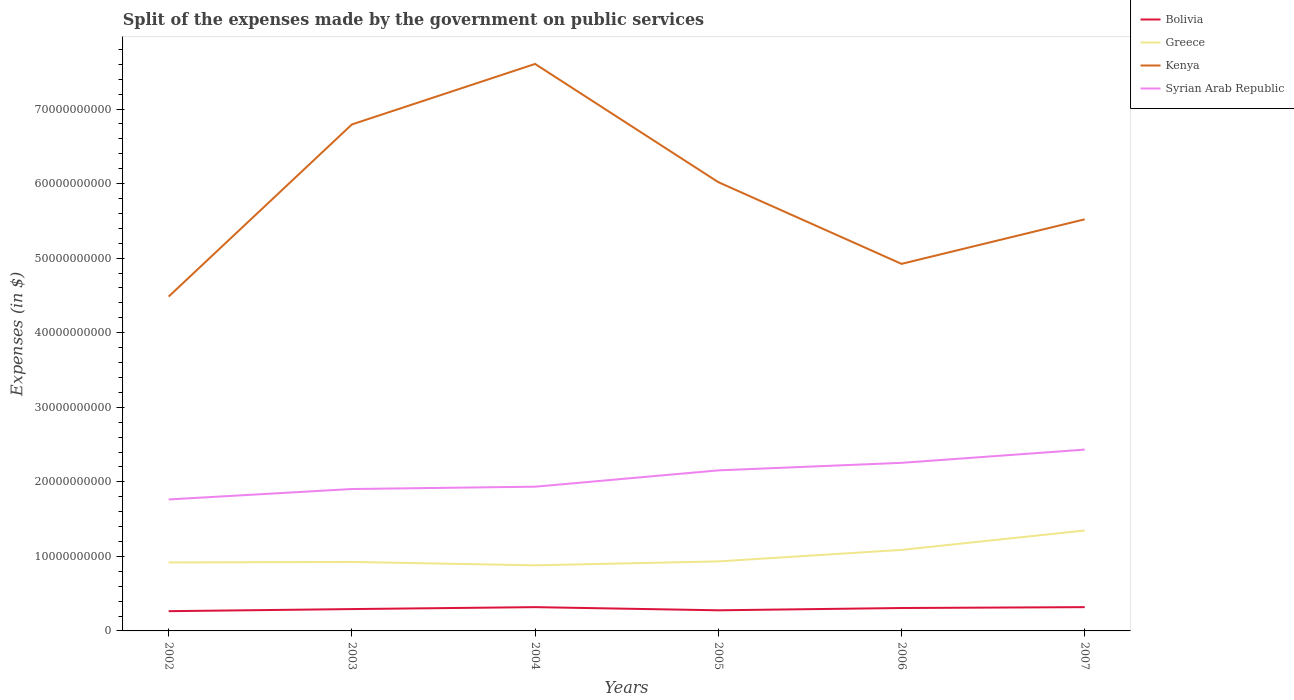Is the number of lines equal to the number of legend labels?
Keep it short and to the point. Yes. Across all years, what is the maximum expenses made by the government on public services in Bolivia?
Keep it short and to the point. 2.65e+09. In which year was the expenses made by the government on public services in Greece maximum?
Your answer should be compact. 2004. What is the total expenses made by the government on public services in Syrian Arab Republic in the graph?
Ensure brevity in your answer.  -3.90e+09. What is the difference between the highest and the second highest expenses made by the government on public services in Kenya?
Your answer should be very brief. 3.12e+1. What is the difference between the highest and the lowest expenses made by the government on public services in Kenya?
Your answer should be compact. 3. How many lines are there?
Your response must be concise. 4. How many years are there in the graph?
Ensure brevity in your answer.  6. Where does the legend appear in the graph?
Keep it short and to the point. Top right. How many legend labels are there?
Your answer should be very brief. 4. What is the title of the graph?
Your answer should be very brief. Split of the expenses made by the government on public services. Does "Suriname" appear as one of the legend labels in the graph?
Make the answer very short. No. What is the label or title of the X-axis?
Your answer should be very brief. Years. What is the label or title of the Y-axis?
Make the answer very short. Expenses (in $). What is the Expenses (in $) of Bolivia in 2002?
Make the answer very short. 2.65e+09. What is the Expenses (in $) in Greece in 2002?
Provide a succinct answer. 9.18e+09. What is the Expenses (in $) of Kenya in 2002?
Your answer should be compact. 4.49e+1. What is the Expenses (in $) in Syrian Arab Republic in 2002?
Your answer should be compact. 1.76e+1. What is the Expenses (in $) in Bolivia in 2003?
Give a very brief answer. 2.93e+09. What is the Expenses (in $) in Greece in 2003?
Your answer should be very brief. 9.25e+09. What is the Expenses (in $) in Kenya in 2003?
Ensure brevity in your answer.  6.79e+1. What is the Expenses (in $) of Syrian Arab Republic in 2003?
Keep it short and to the point. 1.90e+1. What is the Expenses (in $) of Bolivia in 2004?
Make the answer very short. 3.19e+09. What is the Expenses (in $) of Greece in 2004?
Provide a short and direct response. 8.80e+09. What is the Expenses (in $) in Kenya in 2004?
Offer a very short reply. 7.61e+1. What is the Expenses (in $) of Syrian Arab Republic in 2004?
Offer a very short reply. 1.93e+1. What is the Expenses (in $) of Bolivia in 2005?
Offer a very short reply. 2.77e+09. What is the Expenses (in $) in Greece in 2005?
Offer a terse response. 9.33e+09. What is the Expenses (in $) of Kenya in 2005?
Give a very brief answer. 6.02e+1. What is the Expenses (in $) of Syrian Arab Republic in 2005?
Your response must be concise. 2.15e+1. What is the Expenses (in $) in Bolivia in 2006?
Offer a terse response. 3.07e+09. What is the Expenses (in $) in Greece in 2006?
Your response must be concise. 1.09e+1. What is the Expenses (in $) of Kenya in 2006?
Provide a succinct answer. 4.92e+1. What is the Expenses (in $) in Syrian Arab Republic in 2006?
Your answer should be compact. 2.25e+1. What is the Expenses (in $) in Bolivia in 2007?
Give a very brief answer. 3.19e+09. What is the Expenses (in $) in Greece in 2007?
Your response must be concise. 1.35e+1. What is the Expenses (in $) in Kenya in 2007?
Provide a short and direct response. 5.52e+1. What is the Expenses (in $) of Syrian Arab Republic in 2007?
Your answer should be very brief. 2.43e+1. Across all years, what is the maximum Expenses (in $) of Bolivia?
Ensure brevity in your answer.  3.19e+09. Across all years, what is the maximum Expenses (in $) in Greece?
Your answer should be compact. 1.35e+1. Across all years, what is the maximum Expenses (in $) of Kenya?
Your response must be concise. 7.61e+1. Across all years, what is the maximum Expenses (in $) in Syrian Arab Republic?
Your answer should be very brief. 2.43e+1. Across all years, what is the minimum Expenses (in $) in Bolivia?
Make the answer very short. 2.65e+09. Across all years, what is the minimum Expenses (in $) of Greece?
Give a very brief answer. 8.80e+09. Across all years, what is the minimum Expenses (in $) in Kenya?
Provide a short and direct response. 4.49e+1. Across all years, what is the minimum Expenses (in $) in Syrian Arab Republic?
Your response must be concise. 1.76e+1. What is the total Expenses (in $) in Bolivia in the graph?
Offer a terse response. 1.78e+1. What is the total Expenses (in $) of Greece in the graph?
Offer a terse response. 6.09e+1. What is the total Expenses (in $) of Kenya in the graph?
Make the answer very short. 3.53e+11. What is the total Expenses (in $) of Syrian Arab Republic in the graph?
Keep it short and to the point. 1.24e+11. What is the difference between the Expenses (in $) in Bolivia in 2002 and that in 2003?
Offer a very short reply. -2.81e+08. What is the difference between the Expenses (in $) of Greece in 2002 and that in 2003?
Your answer should be very brief. -7.00e+07. What is the difference between the Expenses (in $) of Kenya in 2002 and that in 2003?
Your answer should be compact. -2.31e+1. What is the difference between the Expenses (in $) of Syrian Arab Republic in 2002 and that in 2003?
Your response must be concise. -1.40e+09. What is the difference between the Expenses (in $) in Bolivia in 2002 and that in 2004?
Your answer should be very brief. -5.42e+08. What is the difference between the Expenses (in $) in Greece in 2002 and that in 2004?
Your answer should be compact. 3.84e+08. What is the difference between the Expenses (in $) of Kenya in 2002 and that in 2004?
Your answer should be compact. -3.12e+1. What is the difference between the Expenses (in $) in Syrian Arab Republic in 2002 and that in 2004?
Make the answer very short. -1.71e+09. What is the difference between the Expenses (in $) in Bolivia in 2002 and that in 2005?
Ensure brevity in your answer.  -1.18e+08. What is the difference between the Expenses (in $) in Greece in 2002 and that in 2005?
Your answer should be compact. -1.44e+08. What is the difference between the Expenses (in $) in Kenya in 2002 and that in 2005?
Your response must be concise. -1.53e+1. What is the difference between the Expenses (in $) in Syrian Arab Republic in 2002 and that in 2005?
Keep it short and to the point. -3.90e+09. What is the difference between the Expenses (in $) in Bolivia in 2002 and that in 2006?
Your answer should be compact. -4.25e+08. What is the difference between the Expenses (in $) of Greece in 2002 and that in 2006?
Your answer should be compact. -1.69e+09. What is the difference between the Expenses (in $) of Kenya in 2002 and that in 2006?
Your answer should be compact. -4.39e+09. What is the difference between the Expenses (in $) of Syrian Arab Republic in 2002 and that in 2006?
Provide a succinct answer. -4.91e+09. What is the difference between the Expenses (in $) in Bolivia in 2002 and that in 2007?
Give a very brief answer. -5.41e+08. What is the difference between the Expenses (in $) of Greece in 2002 and that in 2007?
Offer a terse response. -4.29e+09. What is the difference between the Expenses (in $) in Kenya in 2002 and that in 2007?
Offer a very short reply. -1.04e+1. What is the difference between the Expenses (in $) in Syrian Arab Republic in 2002 and that in 2007?
Provide a short and direct response. -6.68e+09. What is the difference between the Expenses (in $) in Bolivia in 2003 and that in 2004?
Your response must be concise. -2.61e+08. What is the difference between the Expenses (in $) in Greece in 2003 and that in 2004?
Give a very brief answer. 4.54e+08. What is the difference between the Expenses (in $) in Kenya in 2003 and that in 2004?
Provide a succinct answer. -8.12e+09. What is the difference between the Expenses (in $) of Syrian Arab Republic in 2003 and that in 2004?
Provide a succinct answer. -3.12e+08. What is the difference between the Expenses (in $) of Bolivia in 2003 and that in 2005?
Offer a terse response. 1.63e+08. What is the difference between the Expenses (in $) of Greece in 2003 and that in 2005?
Ensure brevity in your answer.  -7.40e+07. What is the difference between the Expenses (in $) in Kenya in 2003 and that in 2005?
Keep it short and to the point. 7.74e+09. What is the difference between the Expenses (in $) of Syrian Arab Republic in 2003 and that in 2005?
Offer a very short reply. -2.50e+09. What is the difference between the Expenses (in $) in Bolivia in 2003 and that in 2006?
Make the answer very short. -1.43e+08. What is the difference between the Expenses (in $) in Greece in 2003 and that in 2006?
Give a very brief answer. -1.62e+09. What is the difference between the Expenses (in $) of Kenya in 2003 and that in 2006?
Your answer should be very brief. 1.87e+1. What is the difference between the Expenses (in $) in Syrian Arab Republic in 2003 and that in 2006?
Your answer should be very brief. -3.51e+09. What is the difference between the Expenses (in $) of Bolivia in 2003 and that in 2007?
Offer a terse response. -2.60e+08. What is the difference between the Expenses (in $) in Greece in 2003 and that in 2007?
Your answer should be compact. -4.22e+09. What is the difference between the Expenses (in $) in Kenya in 2003 and that in 2007?
Offer a terse response. 1.27e+1. What is the difference between the Expenses (in $) in Syrian Arab Republic in 2003 and that in 2007?
Offer a terse response. -5.29e+09. What is the difference between the Expenses (in $) in Bolivia in 2004 and that in 2005?
Give a very brief answer. 4.24e+08. What is the difference between the Expenses (in $) in Greece in 2004 and that in 2005?
Offer a terse response. -5.28e+08. What is the difference between the Expenses (in $) in Kenya in 2004 and that in 2005?
Your answer should be very brief. 1.59e+1. What is the difference between the Expenses (in $) in Syrian Arab Republic in 2004 and that in 2005?
Keep it short and to the point. -2.19e+09. What is the difference between the Expenses (in $) in Bolivia in 2004 and that in 2006?
Make the answer very short. 1.18e+08. What is the difference between the Expenses (in $) in Greece in 2004 and that in 2006?
Your answer should be compact. -2.07e+09. What is the difference between the Expenses (in $) of Kenya in 2004 and that in 2006?
Offer a very short reply. 2.68e+1. What is the difference between the Expenses (in $) in Syrian Arab Republic in 2004 and that in 2006?
Give a very brief answer. -3.20e+09. What is the difference between the Expenses (in $) of Bolivia in 2004 and that in 2007?
Give a very brief answer. 8.21e+05. What is the difference between the Expenses (in $) in Greece in 2004 and that in 2007?
Offer a very short reply. -4.67e+09. What is the difference between the Expenses (in $) of Kenya in 2004 and that in 2007?
Provide a short and direct response. 2.08e+1. What is the difference between the Expenses (in $) of Syrian Arab Republic in 2004 and that in 2007?
Your answer should be compact. -4.97e+09. What is the difference between the Expenses (in $) in Bolivia in 2005 and that in 2006?
Your answer should be very brief. -3.06e+08. What is the difference between the Expenses (in $) of Greece in 2005 and that in 2006?
Your answer should be very brief. -1.54e+09. What is the difference between the Expenses (in $) in Kenya in 2005 and that in 2006?
Your answer should be compact. 1.10e+1. What is the difference between the Expenses (in $) of Syrian Arab Republic in 2005 and that in 2006?
Your answer should be compact. -1.01e+09. What is the difference between the Expenses (in $) of Bolivia in 2005 and that in 2007?
Your answer should be very brief. -4.23e+08. What is the difference between the Expenses (in $) of Greece in 2005 and that in 2007?
Your response must be concise. -4.14e+09. What is the difference between the Expenses (in $) of Kenya in 2005 and that in 2007?
Offer a terse response. 4.99e+09. What is the difference between the Expenses (in $) in Syrian Arab Republic in 2005 and that in 2007?
Give a very brief answer. -2.79e+09. What is the difference between the Expenses (in $) of Bolivia in 2006 and that in 2007?
Provide a succinct answer. -1.17e+08. What is the difference between the Expenses (in $) of Greece in 2006 and that in 2007?
Offer a terse response. -2.60e+09. What is the difference between the Expenses (in $) of Kenya in 2006 and that in 2007?
Your response must be concise. -5.98e+09. What is the difference between the Expenses (in $) of Syrian Arab Republic in 2006 and that in 2007?
Give a very brief answer. -1.78e+09. What is the difference between the Expenses (in $) in Bolivia in 2002 and the Expenses (in $) in Greece in 2003?
Your answer should be very brief. -6.60e+09. What is the difference between the Expenses (in $) of Bolivia in 2002 and the Expenses (in $) of Kenya in 2003?
Ensure brevity in your answer.  -6.53e+1. What is the difference between the Expenses (in $) of Bolivia in 2002 and the Expenses (in $) of Syrian Arab Republic in 2003?
Offer a very short reply. -1.64e+1. What is the difference between the Expenses (in $) in Greece in 2002 and the Expenses (in $) in Kenya in 2003?
Provide a succinct answer. -5.88e+1. What is the difference between the Expenses (in $) of Greece in 2002 and the Expenses (in $) of Syrian Arab Republic in 2003?
Keep it short and to the point. -9.85e+09. What is the difference between the Expenses (in $) in Kenya in 2002 and the Expenses (in $) in Syrian Arab Republic in 2003?
Offer a terse response. 2.58e+1. What is the difference between the Expenses (in $) in Bolivia in 2002 and the Expenses (in $) in Greece in 2004?
Ensure brevity in your answer.  -6.15e+09. What is the difference between the Expenses (in $) of Bolivia in 2002 and the Expenses (in $) of Kenya in 2004?
Offer a very short reply. -7.34e+1. What is the difference between the Expenses (in $) in Bolivia in 2002 and the Expenses (in $) in Syrian Arab Republic in 2004?
Ensure brevity in your answer.  -1.67e+1. What is the difference between the Expenses (in $) in Greece in 2002 and the Expenses (in $) in Kenya in 2004?
Your response must be concise. -6.69e+1. What is the difference between the Expenses (in $) in Greece in 2002 and the Expenses (in $) in Syrian Arab Republic in 2004?
Keep it short and to the point. -1.02e+1. What is the difference between the Expenses (in $) in Kenya in 2002 and the Expenses (in $) in Syrian Arab Republic in 2004?
Provide a succinct answer. 2.55e+1. What is the difference between the Expenses (in $) in Bolivia in 2002 and the Expenses (in $) in Greece in 2005?
Make the answer very short. -6.68e+09. What is the difference between the Expenses (in $) of Bolivia in 2002 and the Expenses (in $) of Kenya in 2005?
Make the answer very short. -5.75e+1. What is the difference between the Expenses (in $) of Bolivia in 2002 and the Expenses (in $) of Syrian Arab Republic in 2005?
Ensure brevity in your answer.  -1.89e+1. What is the difference between the Expenses (in $) of Greece in 2002 and the Expenses (in $) of Kenya in 2005?
Give a very brief answer. -5.10e+1. What is the difference between the Expenses (in $) of Greece in 2002 and the Expenses (in $) of Syrian Arab Republic in 2005?
Provide a succinct answer. -1.24e+1. What is the difference between the Expenses (in $) in Kenya in 2002 and the Expenses (in $) in Syrian Arab Republic in 2005?
Provide a short and direct response. 2.33e+1. What is the difference between the Expenses (in $) in Bolivia in 2002 and the Expenses (in $) in Greece in 2006?
Your answer should be very brief. -8.22e+09. What is the difference between the Expenses (in $) of Bolivia in 2002 and the Expenses (in $) of Kenya in 2006?
Your response must be concise. -4.66e+1. What is the difference between the Expenses (in $) in Bolivia in 2002 and the Expenses (in $) in Syrian Arab Republic in 2006?
Your answer should be very brief. -1.99e+1. What is the difference between the Expenses (in $) in Greece in 2002 and the Expenses (in $) in Kenya in 2006?
Your answer should be compact. -4.01e+1. What is the difference between the Expenses (in $) in Greece in 2002 and the Expenses (in $) in Syrian Arab Republic in 2006?
Provide a succinct answer. -1.34e+1. What is the difference between the Expenses (in $) in Kenya in 2002 and the Expenses (in $) in Syrian Arab Republic in 2006?
Keep it short and to the point. 2.23e+1. What is the difference between the Expenses (in $) of Bolivia in 2002 and the Expenses (in $) of Greece in 2007?
Provide a short and direct response. -1.08e+1. What is the difference between the Expenses (in $) in Bolivia in 2002 and the Expenses (in $) in Kenya in 2007?
Make the answer very short. -5.26e+1. What is the difference between the Expenses (in $) in Bolivia in 2002 and the Expenses (in $) in Syrian Arab Republic in 2007?
Your answer should be compact. -2.17e+1. What is the difference between the Expenses (in $) in Greece in 2002 and the Expenses (in $) in Kenya in 2007?
Your response must be concise. -4.60e+1. What is the difference between the Expenses (in $) in Greece in 2002 and the Expenses (in $) in Syrian Arab Republic in 2007?
Give a very brief answer. -1.51e+1. What is the difference between the Expenses (in $) in Kenya in 2002 and the Expenses (in $) in Syrian Arab Republic in 2007?
Provide a succinct answer. 2.05e+1. What is the difference between the Expenses (in $) in Bolivia in 2003 and the Expenses (in $) in Greece in 2004?
Keep it short and to the point. -5.87e+09. What is the difference between the Expenses (in $) in Bolivia in 2003 and the Expenses (in $) in Kenya in 2004?
Offer a terse response. -7.31e+1. What is the difference between the Expenses (in $) in Bolivia in 2003 and the Expenses (in $) in Syrian Arab Republic in 2004?
Offer a terse response. -1.64e+1. What is the difference between the Expenses (in $) in Greece in 2003 and the Expenses (in $) in Kenya in 2004?
Offer a terse response. -6.68e+1. What is the difference between the Expenses (in $) in Greece in 2003 and the Expenses (in $) in Syrian Arab Republic in 2004?
Your answer should be very brief. -1.01e+1. What is the difference between the Expenses (in $) in Kenya in 2003 and the Expenses (in $) in Syrian Arab Republic in 2004?
Your response must be concise. 4.86e+1. What is the difference between the Expenses (in $) in Bolivia in 2003 and the Expenses (in $) in Greece in 2005?
Your answer should be very brief. -6.40e+09. What is the difference between the Expenses (in $) of Bolivia in 2003 and the Expenses (in $) of Kenya in 2005?
Provide a succinct answer. -5.73e+1. What is the difference between the Expenses (in $) of Bolivia in 2003 and the Expenses (in $) of Syrian Arab Republic in 2005?
Offer a very short reply. -1.86e+1. What is the difference between the Expenses (in $) of Greece in 2003 and the Expenses (in $) of Kenya in 2005?
Your answer should be compact. -5.09e+1. What is the difference between the Expenses (in $) of Greece in 2003 and the Expenses (in $) of Syrian Arab Republic in 2005?
Ensure brevity in your answer.  -1.23e+1. What is the difference between the Expenses (in $) of Kenya in 2003 and the Expenses (in $) of Syrian Arab Republic in 2005?
Provide a short and direct response. 4.64e+1. What is the difference between the Expenses (in $) of Bolivia in 2003 and the Expenses (in $) of Greece in 2006?
Provide a succinct answer. -7.94e+09. What is the difference between the Expenses (in $) of Bolivia in 2003 and the Expenses (in $) of Kenya in 2006?
Your response must be concise. -4.63e+1. What is the difference between the Expenses (in $) of Bolivia in 2003 and the Expenses (in $) of Syrian Arab Republic in 2006?
Keep it short and to the point. -1.96e+1. What is the difference between the Expenses (in $) in Greece in 2003 and the Expenses (in $) in Kenya in 2006?
Your answer should be very brief. -4.00e+1. What is the difference between the Expenses (in $) of Greece in 2003 and the Expenses (in $) of Syrian Arab Republic in 2006?
Your answer should be compact. -1.33e+1. What is the difference between the Expenses (in $) of Kenya in 2003 and the Expenses (in $) of Syrian Arab Republic in 2006?
Provide a succinct answer. 4.54e+1. What is the difference between the Expenses (in $) of Bolivia in 2003 and the Expenses (in $) of Greece in 2007?
Provide a succinct answer. -1.05e+1. What is the difference between the Expenses (in $) in Bolivia in 2003 and the Expenses (in $) in Kenya in 2007?
Provide a succinct answer. -5.23e+1. What is the difference between the Expenses (in $) in Bolivia in 2003 and the Expenses (in $) in Syrian Arab Republic in 2007?
Your answer should be very brief. -2.14e+1. What is the difference between the Expenses (in $) of Greece in 2003 and the Expenses (in $) of Kenya in 2007?
Give a very brief answer. -4.60e+1. What is the difference between the Expenses (in $) in Greece in 2003 and the Expenses (in $) in Syrian Arab Republic in 2007?
Ensure brevity in your answer.  -1.51e+1. What is the difference between the Expenses (in $) of Kenya in 2003 and the Expenses (in $) of Syrian Arab Republic in 2007?
Keep it short and to the point. 4.36e+1. What is the difference between the Expenses (in $) in Bolivia in 2004 and the Expenses (in $) in Greece in 2005?
Make the answer very short. -6.14e+09. What is the difference between the Expenses (in $) in Bolivia in 2004 and the Expenses (in $) in Kenya in 2005?
Keep it short and to the point. -5.70e+1. What is the difference between the Expenses (in $) of Bolivia in 2004 and the Expenses (in $) of Syrian Arab Republic in 2005?
Ensure brevity in your answer.  -1.83e+1. What is the difference between the Expenses (in $) in Greece in 2004 and the Expenses (in $) in Kenya in 2005?
Make the answer very short. -5.14e+1. What is the difference between the Expenses (in $) in Greece in 2004 and the Expenses (in $) in Syrian Arab Republic in 2005?
Offer a terse response. -1.27e+1. What is the difference between the Expenses (in $) of Kenya in 2004 and the Expenses (in $) of Syrian Arab Republic in 2005?
Your response must be concise. 5.45e+1. What is the difference between the Expenses (in $) of Bolivia in 2004 and the Expenses (in $) of Greece in 2006?
Ensure brevity in your answer.  -7.68e+09. What is the difference between the Expenses (in $) of Bolivia in 2004 and the Expenses (in $) of Kenya in 2006?
Keep it short and to the point. -4.60e+1. What is the difference between the Expenses (in $) in Bolivia in 2004 and the Expenses (in $) in Syrian Arab Republic in 2006?
Your answer should be very brief. -1.94e+1. What is the difference between the Expenses (in $) of Greece in 2004 and the Expenses (in $) of Kenya in 2006?
Offer a terse response. -4.04e+1. What is the difference between the Expenses (in $) in Greece in 2004 and the Expenses (in $) in Syrian Arab Republic in 2006?
Offer a terse response. -1.37e+1. What is the difference between the Expenses (in $) in Kenya in 2004 and the Expenses (in $) in Syrian Arab Republic in 2006?
Provide a short and direct response. 5.35e+1. What is the difference between the Expenses (in $) of Bolivia in 2004 and the Expenses (in $) of Greece in 2007?
Ensure brevity in your answer.  -1.03e+1. What is the difference between the Expenses (in $) of Bolivia in 2004 and the Expenses (in $) of Kenya in 2007?
Your answer should be very brief. -5.20e+1. What is the difference between the Expenses (in $) in Bolivia in 2004 and the Expenses (in $) in Syrian Arab Republic in 2007?
Provide a succinct answer. -2.11e+1. What is the difference between the Expenses (in $) of Greece in 2004 and the Expenses (in $) of Kenya in 2007?
Make the answer very short. -4.64e+1. What is the difference between the Expenses (in $) in Greece in 2004 and the Expenses (in $) in Syrian Arab Republic in 2007?
Make the answer very short. -1.55e+1. What is the difference between the Expenses (in $) in Kenya in 2004 and the Expenses (in $) in Syrian Arab Republic in 2007?
Make the answer very short. 5.17e+1. What is the difference between the Expenses (in $) in Bolivia in 2005 and the Expenses (in $) in Greece in 2006?
Make the answer very short. -8.10e+09. What is the difference between the Expenses (in $) of Bolivia in 2005 and the Expenses (in $) of Kenya in 2006?
Make the answer very short. -4.65e+1. What is the difference between the Expenses (in $) in Bolivia in 2005 and the Expenses (in $) in Syrian Arab Republic in 2006?
Your answer should be very brief. -1.98e+1. What is the difference between the Expenses (in $) of Greece in 2005 and the Expenses (in $) of Kenya in 2006?
Your answer should be compact. -3.99e+1. What is the difference between the Expenses (in $) in Greece in 2005 and the Expenses (in $) in Syrian Arab Republic in 2006?
Your answer should be very brief. -1.32e+1. What is the difference between the Expenses (in $) of Kenya in 2005 and the Expenses (in $) of Syrian Arab Republic in 2006?
Ensure brevity in your answer.  3.77e+1. What is the difference between the Expenses (in $) in Bolivia in 2005 and the Expenses (in $) in Greece in 2007?
Your answer should be compact. -1.07e+1. What is the difference between the Expenses (in $) in Bolivia in 2005 and the Expenses (in $) in Kenya in 2007?
Your answer should be compact. -5.24e+1. What is the difference between the Expenses (in $) of Bolivia in 2005 and the Expenses (in $) of Syrian Arab Republic in 2007?
Provide a succinct answer. -2.16e+1. What is the difference between the Expenses (in $) in Greece in 2005 and the Expenses (in $) in Kenya in 2007?
Provide a short and direct response. -4.59e+1. What is the difference between the Expenses (in $) in Greece in 2005 and the Expenses (in $) in Syrian Arab Republic in 2007?
Ensure brevity in your answer.  -1.50e+1. What is the difference between the Expenses (in $) of Kenya in 2005 and the Expenses (in $) of Syrian Arab Republic in 2007?
Your answer should be very brief. 3.59e+1. What is the difference between the Expenses (in $) in Bolivia in 2006 and the Expenses (in $) in Greece in 2007?
Ensure brevity in your answer.  -1.04e+1. What is the difference between the Expenses (in $) of Bolivia in 2006 and the Expenses (in $) of Kenya in 2007?
Make the answer very short. -5.21e+1. What is the difference between the Expenses (in $) in Bolivia in 2006 and the Expenses (in $) in Syrian Arab Republic in 2007?
Provide a short and direct response. -2.12e+1. What is the difference between the Expenses (in $) in Greece in 2006 and the Expenses (in $) in Kenya in 2007?
Offer a terse response. -4.43e+1. What is the difference between the Expenses (in $) in Greece in 2006 and the Expenses (in $) in Syrian Arab Republic in 2007?
Make the answer very short. -1.35e+1. What is the difference between the Expenses (in $) in Kenya in 2006 and the Expenses (in $) in Syrian Arab Republic in 2007?
Your answer should be compact. 2.49e+1. What is the average Expenses (in $) in Bolivia per year?
Keep it short and to the point. 2.97e+09. What is the average Expenses (in $) in Greece per year?
Your answer should be very brief. 1.01e+1. What is the average Expenses (in $) in Kenya per year?
Ensure brevity in your answer.  5.89e+1. What is the average Expenses (in $) in Syrian Arab Republic per year?
Your response must be concise. 2.07e+1. In the year 2002, what is the difference between the Expenses (in $) of Bolivia and Expenses (in $) of Greece?
Your response must be concise. -6.53e+09. In the year 2002, what is the difference between the Expenses (in $) of Bolivia and Expenses (in $) of Kenya?
Provide a succinct answer. -4.22e+1. In the year 2002, what is the difference between the Expenses (in $) in Bolivia and Expenses (in $) in Syrian Arab Republic?
Your answer should be compact. -1.50e+1. In the year 2002, what is the difference between the Expenses (in $) of Greece and Expenses (in $) of Kenya?
Offer a terse response. -3.57e+1. In the year 2002, what is the difference between the Expenses (in $) in Greece and Expenses (in $) in Syrian Arab Republic?
Your response must be concise. -8.45e+09. In the year 2002, what is the difference between the Expenses (in $) in Kenya and Expenses (in $) in Syrian Arab Republic?
Provide a succinct answer. 2.72e+1. In the year 2003, what is the difference between the Expenses (in $) in Bolivia and Expenses (in $) in Greece?
Keep it short and to the point. -6.32e+09. In the year 2003, what is the difference between the Expenses (in $) in Bolivia and Expenses (in $) in Kenya?
Provide a succinct answer. -6.50e+1. In the year 2003, what is the difference between the Expenses (in $) in Bolivia and Expenses (in $) in Syrian Arab Republic?
Keep it short and to the point. -1.61e+1. In the year 2003, what is the difference between the Expenses (in $) of Greece and Expenses (in $) of Kenya?
Offer a very short reply. -5.87e+1. In the year 2003, what is the difference between the Expenses (in $) in Greece and Expenses (in $) in Syrian Arab Republic?
Your answer should be compact. -9.78e+09. In the year 2003, what is the difference between the Expenses (in $) in Kenya and Expenses (in $) in Syrian Arab Republic?
Keep it short and to the point. 4.89e+1. In the year 2004, what is the difference between the Expenses (in $) in Bolivia and Expenses (in $) in Greece?
Provide a succinct answer. -5.61e+09. In the year 2004, what is the difference between the Expenses (in $) in Bolivia and Expenses (in $) in Kenya?
Give a very brief answer. -7.29e+1. In the year 2004, what is the difference between the Expenses (in $) in Bolivia and Expenses (in $) in Syrian Arab Republic?
Provide a short and direct response. -1.62e+1. In the year 2004, what is the difference between the Expenses (in $) in Greece and Expenses (in $) in Kenya?
Your answer should be compact. -6.73e+1. In the year 2004, what is the difference between the Expenses (in $) in Greece and Expenses (in $) in Syrian Arab Republic?
Provide a succinct answer. -1.05e+1. In the year 2004, what is the difference between the Expenses (in $) in Kenya and Expenses (in $) in Syrian Arab Republic?
Offer a very short reply. 5.67e+1. In the year 2005, what is the difference between the Expenses (in $) of Bolivia and Expenses (in $) of Greece?
Your answer should be compact. -6.56e+09. In the year 2005, what is the difference between the Expenses (in $) in Bolivia and Expenses (in $) in Kenya?
Offer a terse response. -5.74e+1. In the year 2005, what is the difference between the Expenses (in $) in Bolivia and Expenses (in $) in Syrian Arab Republic?
Give a very brief answer. -1.88e+1. In the year 2005, what is the difference between the Expenses (in $) of Greece and Expenses (in $) of Kenya?
Your response must be concise. -5.09e+1. In the year 2005, what is the difference between the Expenses (in $) of Greece and Expenses (in $) of Syrian Arab Republic?
Provide a short and direct response. -1.22e+1. In the year 2005, what is the difference between the Expenses (in $) of Kenya and Expenses (in $) of Syrian Arab Republic?
Keep it short and to the point. 3.87e+1. In the year 2006, what is the difference between the Expenses (in $) in Bolivia and Expenses (in $) in Greece?
Your answer should be compact. -7.80e+09. In the year 2006, what is the difference between the Expenses (in $) in Bolivia and Expenses (in $) in Kenya?
Ensure brevity in your answer.  -4.62e+1. In the year 2006, what is the difference between the Expenses (in $) in Bolivia and Expenses (in $) in Syrian Arab Republic?
Your answer should be compact. -1.95e+1. In the year 2006, what is the difference between the Expenses (in $) of Greece and Expenses (in $) of Kenya?
Offer a very short reply. -3.84e+1. In the year 2006, what is the difference between the Expenses (in $) in Greece and Expenses (in $) in Syrian Arab Republic?
Your answer should be compact. -1.17e+1. In the year 2006, what is the difference between the Expenses (in $) in Kenya and Expenses (in $) in Syrian Arab Republic?
Your response must be concise. 2.67e+1. In the year 2007, what is the difference between the Expenses (in $) in Bolivia and Expenses (in $) in Greece?
Make the answer very short. -1.03e+1. In the year 2007, what is the difference between the Expenses (in $) in Bolivia and Expenses (in $) in Kenya?
Provide a succinct answer. -5.20e+1. In the year 2007, what is the difference between the Expenses (in $) in Bolivia and Expenses (in $) in Syrian Arab Republic?
Provide a succinct answer. -2.11e+1. In the year 2007, what is the difference between the Expenses (in $) in Greece and Expenses (in $) in Kenya?
Offer a very short reply. -4.17e+1. In the year 2007, what is the difference between the Expenses (in $) in Greece and Expenses (in $) in Syrian Arab Republic?
Your answer should be compact. -1.09e+1. In the year 2007, what is the difference between the Expenses (in $) of Kenya and Expenses (in $) of Syrian Arab Republic?
Provide a short and direct response. 3.09e+1. What is the ratio of the Expenses (in $) of Bolivia in 2002 to that in 2003?
Provide a succinct answer. 0.9. What is the ratio of the Expenses (in $) in Kenya in 2002 to that in 2003?
Offer a terse response. 0.66. What is the ratio of the Expenses (in $) of Syrian Arab Republic in 2002 to that in 2003?
Keep it short and to the point. 0.93. What is the ratio of the Expenses (in $) of Bolivia in 2002 to that in 2004?
Keep it short and to the point. 0.83. What is the ratio of the Expenses (in $) of Greece in 2002 to that in 2004?
Give a very brief answer. 1.04. What is the ratio of the Expenses (in $) in Kenya in 2002 to that in 2004?
Provide a succinct answer. 0.59. What is the ratio of the Expenses (in $) in Syrian Arab Republic in 2002 to that in 2004?
Keep it short and to the point. 0.91. What is the ratio of the Expenses (in $) in Bolivia in 2002 to that in 2005?
Ensure brevity in your answer.  0.96. What is the ratio of the Expenses (in $) of Greece in 2002 to that in 2005?
Make the answer very short. 0.98. What is the ratio of the Expenses (in $) of Kenya in 2002 to that in 2005?
Make the answer very short. 0.75. What is the ratio of the Expenses (in $) in Syrian Arab Republic in 2002 to that in 2005?
Your answer should be compact. 0.82. What is the ratio of the Expenses (in $) in Bolivia in 2002 to that in 2006?
Your answer should be compact. 0.86. What is the ratio of the Expenses (in $) of Greece in 2002 to that in 2006?
Your response must be concise. 0.84. What is the ratio of the Expenses (in $) of Kenya in 2002 to that in 2006?
Give a very brief answer. 0.91. What is the ratio of the Expenses (in $) of Syrian Arab Republic in 2002 to that in 2006?
Your response must be concise. 0.78. What is the ratio of the Expenses (in $) of Bolivia in 2002 to that in 2007?
Give a very brief answer. 0.83. What is the ratio of the Expenses (in $) of Greece in 2002 to that in 2007?
Give a very brief answer. 0.68. What is the ratio of the Expenses (in $) in Kenya in 2002 to that in 2007?
Your answer should be very brief. 0.81. What is the ratio of the Expenses (in $) of Syrian Arab Republic in 2002 to that in 2007?
Your answer should be compact. 0.73. What is the ratio of the Expenses (in $) of Bolivia in 2003 to that in 2004?
Your answer should be compact. 0.92. What is the ratio of the Expenses (in $) in Greece in 2003 to that in 2004?
Your response must be concise. 1.05. What is the ratio of the Expenses (in $) in Kenya in 2003 to that in 2004?
Your answer should be compact. 0.89. What is the ratio of the Expenses (in $) of Syrian Arab Republic in 2003 to that in 2004?
Your response must be concise. 0.98. What is the ratio of the Expenses (in $) in Bolivia in 2003 to that in 2005?
Provide a succinct answer. 1.06. What is the ratio of the Expenses (in $) of Greece in 2003 to that in 2005?
Your response must be concise. 0.99. What is the ratio of the Expenses (in $) of Kenya in 2003 to that in 2005?
Your answer should be very brief. 1.13. What is the ratio of the Expenses (in $) in Syrian Arab Republic in 2003 to that in 2005?
Your response must be concise. 0.88. What is the ratio of the Expenses (in $) of Bolivia in 2003 to that in 2006?
Provide a succinct answer. 0.95. What is the ratio of the Expenses (in $) in Greece in 2003 to that in 2006?
Provide a succinct answer. 0.85. What is the ratio of the Expenses (in $) in Kenya in 2003 to that in 2006?
Your answer should be very brief. 1.38. What is the ratio of the Expenses (in $) of Syrian Arab Republic in 2003 to that in 2006?
Make the answer very short. 0.84. What is the ratio of the Expenses (in $) of Bolivia in 2003 to that in 2007?
Ensure brevity in your answer.  0.92. What is the ratio of the Expenses (in $) in Greece in 2003 to that in 2007?
Give a very brief answer. 0.69. What is the ratio of the Expenses (in $) in Kenya in 2003 to that in 2007?
Keep it short and to the point. 1.23. What is the ratio of the Expenses (in $) in Syrian Arab Republic in 2003 to that in 2007?
Offer a terse response. 0.78. What is the ratio of the Expenses (in $) of Bolivia in 2004 to that in 2005?
Your answer should be compact. 1.15. What is the ratio of the Expenses (in $) in Greece in 2004 to that in 2005?
Offer a terse response. 0.94. What is the ratio of the Expenses (in $) of Kenya in 2004 to that in 2005?
Your response must be concise. 1.26. What is the ratio of the Expenses (in $) in Syrian Arab Republic in 2004 to that in 2005?
Ensure brevity in your answer.  0.9. What is the ratio of the Expenses (in $) in Bolivia in 2004 to that in 2006?
Offer a terse response. 1.04. What is the ratio of the Expenses (in $) in Greece in 2004 to that in 2006?
Your answer should be very brief. 0.81. What is the ratio of the Expenses (in $) in Kenya in 2004 to that in 2006?
Keep it short and to the point. 1.54. What is the ratio of the Expenses (in $) of Syrian Arab Republic in 2004 to that in 2006?
Provide a short and direct response. 0.86. What is the ratio of the Expenses (in $) in Greece in 2004 to that in 2007?
Offer a terse response. 0.65. What is the ratio of the Expenses (in $) in Kenya in 2004 to that in 2007?
Offer a terse response. 1.38. What is the ratio of the Expenses (in $) of Syrian Arab Republic in 2004 to that in 2007?
Make the answer very short. 0.8. What is the ratio of the Expenses (in $) of Bolivia in 2005 to that in 2006?
Offer a very short reply. 0.9. What is the ratio of the Expenses (in $) of Greece in 2005 to that in 2006?
Your response must be concise. 0.86. What is the ratio of the Expenses (in $) in Kenya in 2005 to that in 2006?
Provide a succinct answer. 1.22. What is the ratio of the Expenses (in $) in Syrian Arab Republic in 2005 to that in 2006?
Provide a succinct answer. 0.96. What is the ratio of the Expenses (in $) in Bolivia in 2005 to that in 2007?
Your response must be concise. 0.87. What is the ratio of the Expenses (in $) in Greece in 2005 to that in 2007?
Your answer should be compact. 0.69. What is the ratio of the Expenses (in $) of Kenya in 2005 to that in 2007?
Provide a short and direct response. 1.09. What is the ratio of the Expenses (in $) in Syrian Arab Republic in 2005 to that in 2007?
Keep it short and to the point. 0.89. What is the ratio of the Expenses (in $) of Bolivia in 2006 to that in 2007?
Keep it short and to the point. 0.96. What is the ratio of the Expenses (in $) in Greece in 2006 to that in 2007?
Offer a terse response. 0.81. What is the ratio of the Expenses (in $) of Kenya in 2006 to that in 2007?
Provide a short and direct response. 0.89. What is the ratio of the Expenses (in $) in Syrian Arab Republic in 2006 to that in 2007?
Give a very brief answer. 0.93. What is the difference between the highest and the second highest Expenses (in $) of Bolivia?
Your answer should be very brief. 8.21e+05. What is the difference between the highest and the second highest Expenses (in $) of Greece?
Offer a very short reply. 2.60e+09. What is the difference between the highest and the second highest Expenses (in $) in Kenya?
Give a very brief answer. 8.12e+09. What is the difference between the highest and the second highest Expenses (in $) of Syrian Arab Republic?
Offer a very short reply. 1.78e+09. What is the difference between the highest and the lowest Expenses (in $) of Bolivia?
Your answer should be compact. 5.42e+08. What is the difference between the highest and the lowest Expenses (in $) in Greece?
Make the answer very short. 4.67e+09. What is the difference between the highest and the lowest Expenses (in $) in Kenya?
Your response must be concise. 3.12e+1. What is the difference between the highest and the lowest Expenses (in $) in Syrian Arab Republic?
Your response must be concise. 6.68e+09. 